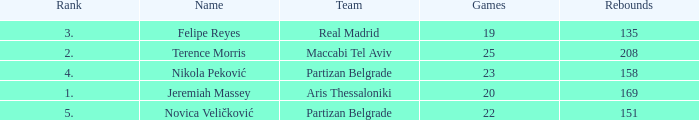What is the number of Games for the Maccabi Tel Aviv Team with less than 208 Rebounds? None. 